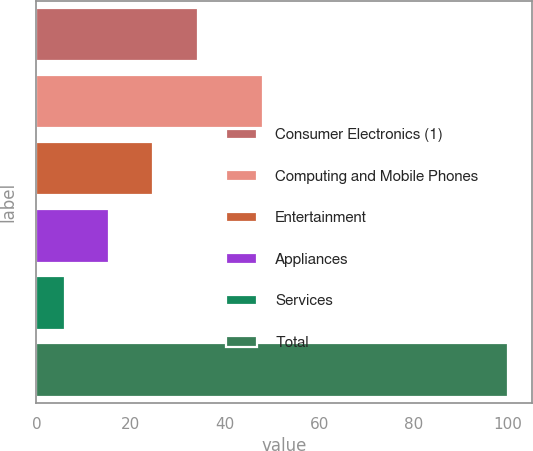<chart> <loc_0><loc_0><loc_500><loc_500><bar_chart><fcel>Consumer Electronics (1)<fcel>Computing and Mobile Phones<fcel>Entertainment<fcel>Appliances<fcel>Services<fcel>Total<nl><fcel>34.2<fcel>48<fcel>24.8<fcel>15.4<fcel>6<fcel>100<nl></chart> 